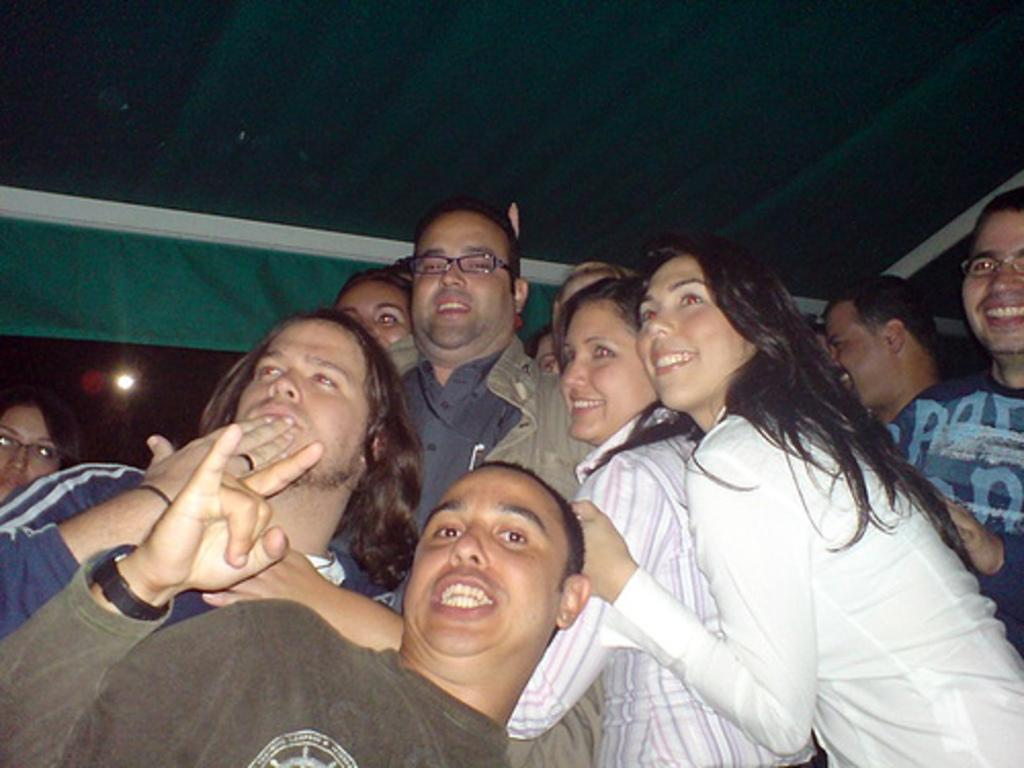What is the general mood of the people in the image? The people in the image are smiling, which suggests a positive or happy mood. How many men are in the group? There are at least two men in the group. Can you describe the woman in the group? The woman in the group is wearing spectacles. What can be seen in the image that provides illumination? There is a light visible in the image. How many thumbs can be seen in the image? There is no information provided about the number of thumbs visible in the image, as the focus is on the people and their appearance. 